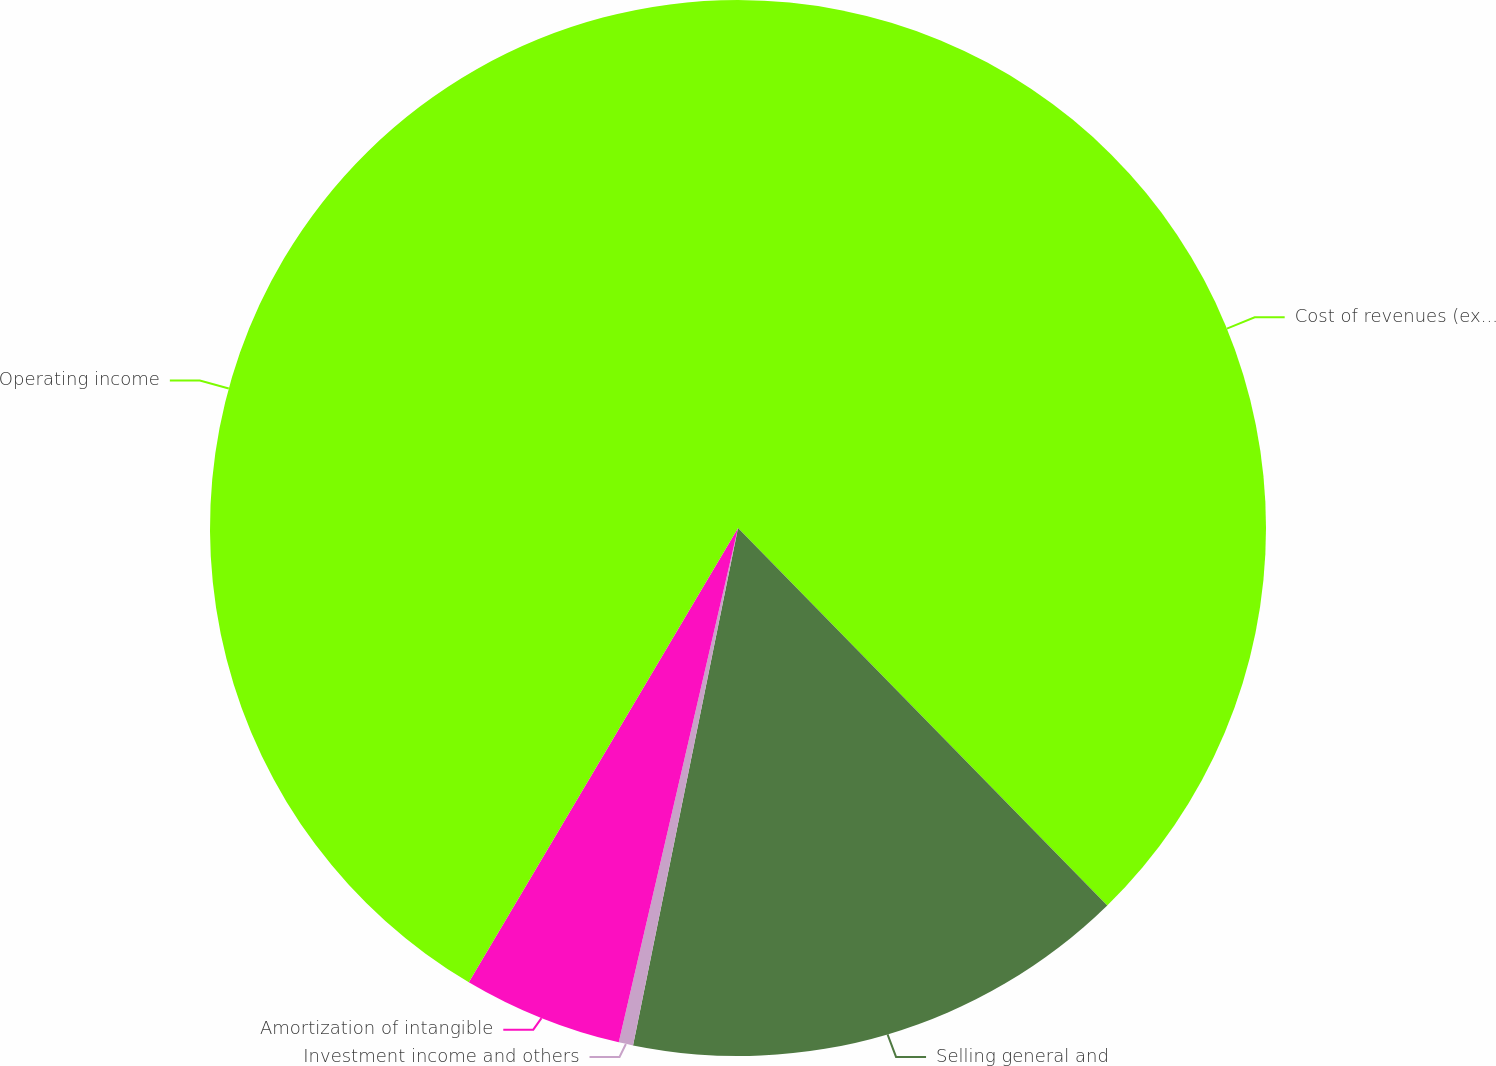<chart> <loc_0><loc_0><loc_500><loc_500><pie_chart><fcel>Cost of revenues (exclusive of<fcel>Selling general and<fcel>Investment income and others<fcel>Amortization of intangible<fcel>Operating income<nl><fcel>37.67%<fcel>15.51%<fcel>0.44%<fcel>4.89%<fcel>41.48%<nl></chart> 